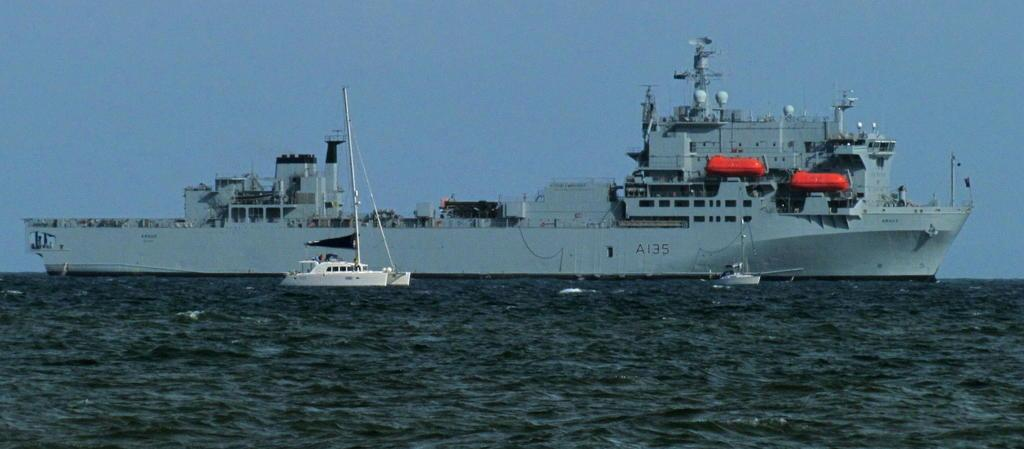<image>
Create a compact narrative representing the image presented. a military grey ship with number A135 in the ocean 